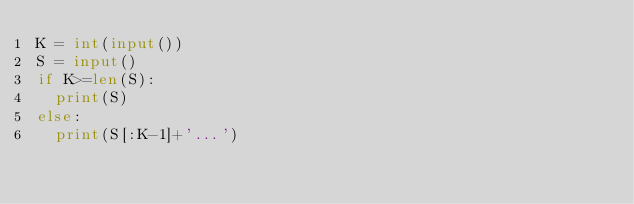<code> <loc_0><loc_0><loc_500><loc_500><_Python_>K = int(input())
S = input()
if K>=len(S):
  print(S)
else:
  print(S[:K-1]+'...')</code> 